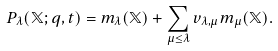<formula> <loc_0><loc_0><loc_500><loc_500>P _ { \lambda } ( \mathbb { X } ; q , t ) = m _ { \lambda } ( \mathbb { X } ) + \sum _ { \mu \leq \lambda } v _ { \lambda , \mu } m _ { \mu } ( \mathbb { X } ) .</formula> 